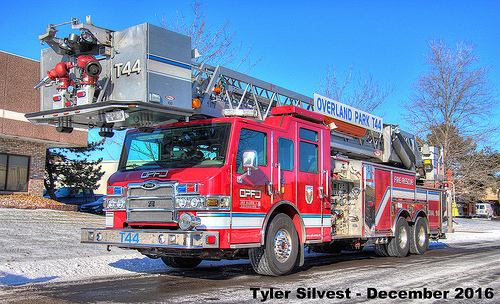<image>
Can you confirm if the ladder is above the door? Yes. The ladder is positioned above the door in the vertical space, higher up in the scene. 